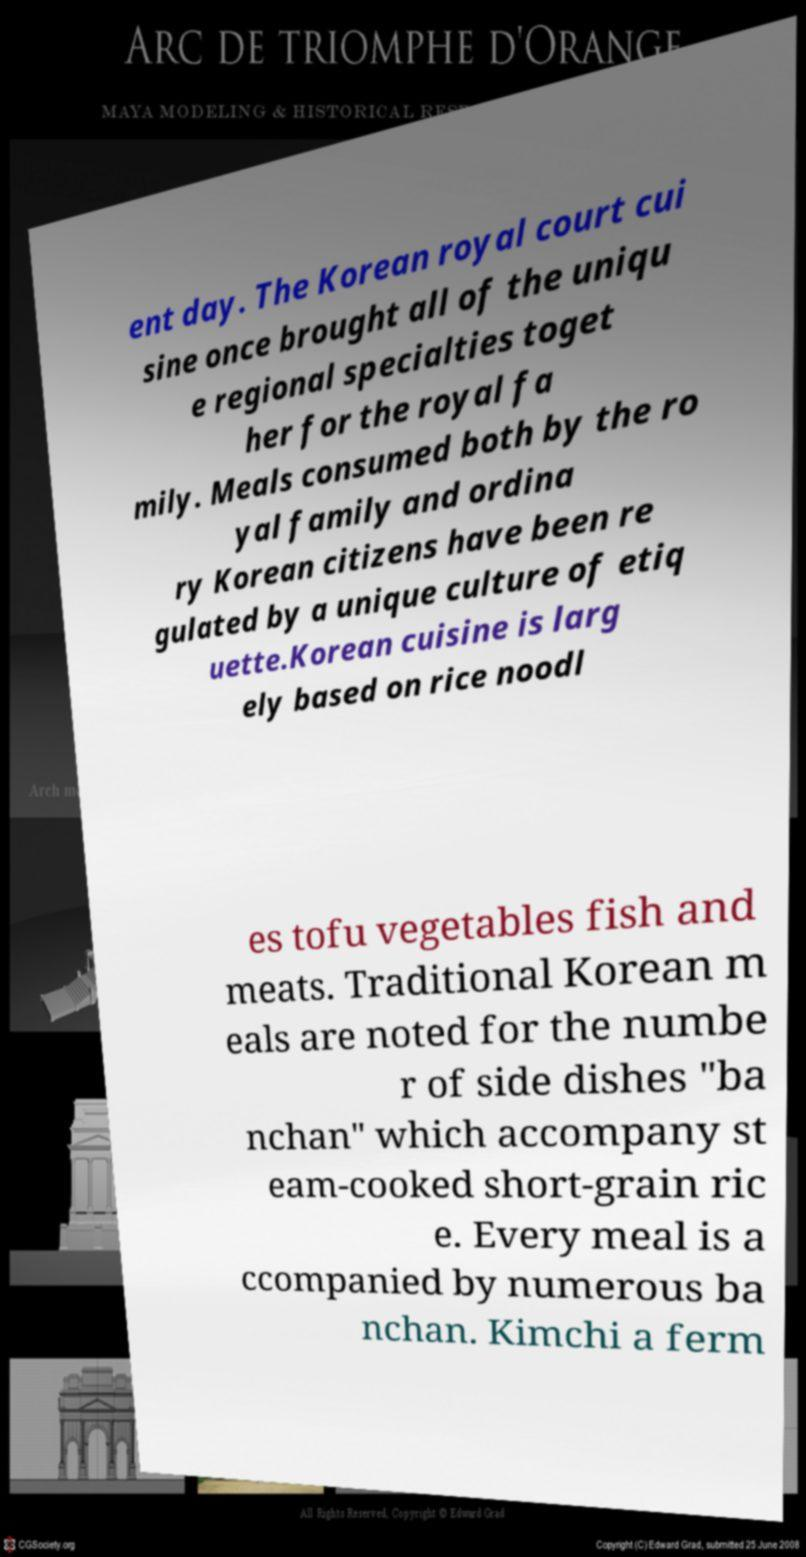There's text embedded in this image that I need extracted. Can you transcribe it verbatim? ent day. The Korean royal court cui sine once brought all of the uniqu e regional specialties toget her for the royal fa mily. Meals consumed both by the ro yal family and ordina ry Korean citizens have been re gulated by a unique culture of etiq uette.Korean cuisine is larg ely based on rice noodl es tofu vegetables fish and meats. Traditional Korean m eals are noted for the numbe r of side dishes "ba nchan" which accompany st eam-cooked short-grain ric e. Every meal is a ccompanied by numerous ba nchan. Kimchi a ferm 